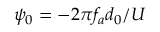<formula> <loc_0><loc_0><loc_500><loc_500>\psi _ { 0 } = - 2 \pi f _ { a } d _ { 0 } / U</formula> 